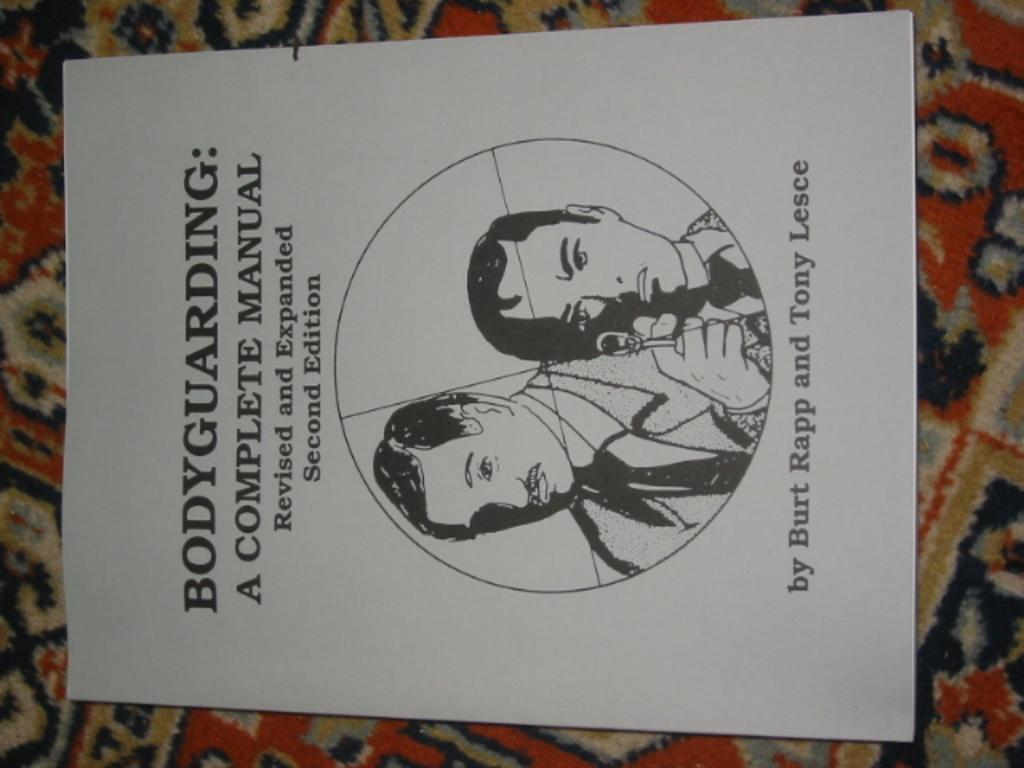Provide a one-sentence caption for the provided image. A body-guarding manual by Burt Rapp and Tony Lesce. 